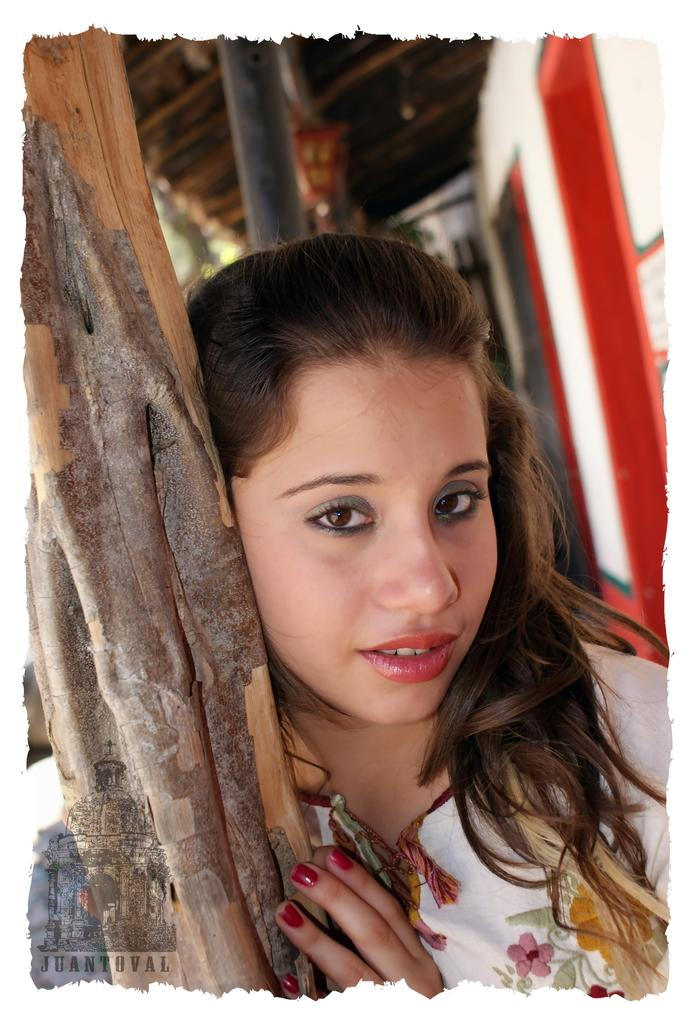Who is present in the image? There is a woman in the image. What is the woman wearing? The woman is wearing a white dress. What expression does the woman have? The woman is smiling. What object is the woman holding? The woman is holding a wooden pole. Can you describe the background of the image? There is a pole, a white wall, and a roof in the background of the image. What type of scarecrow can be seen in the image? There is no scarecrow present in the image. 